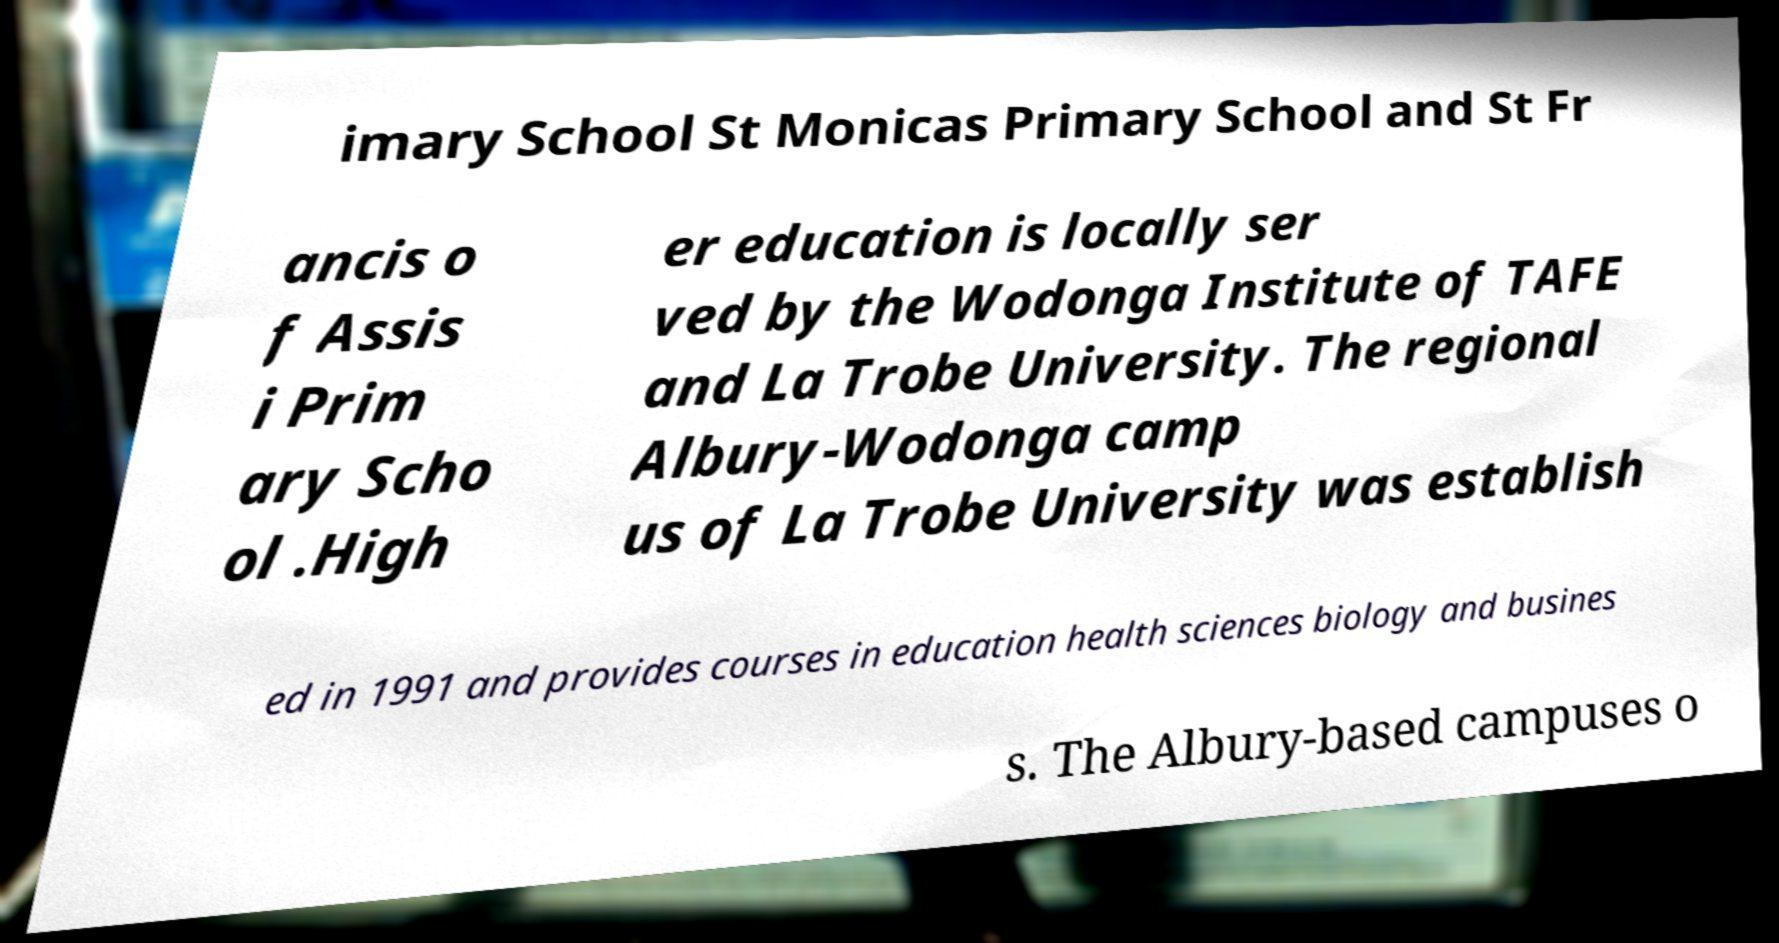Could you extract and type out the text from this image? imary School St Monicas Primary School and St Fr ancis o f Assis i Prim ary Scho ol .High er education is locally ser ved by the Wodonga Institute of TAFE and La Trobe University. The regional Albury-Wodonga camp us of La Trobe University was establish ed in 1991 and provides courses in education health sciences biology and busines s. The Albury-based campuses o 